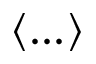Convert formula to latex. <formula><loc_0><loc_0><loc_500><loc_500>\langle \dots \rangle</formula> 